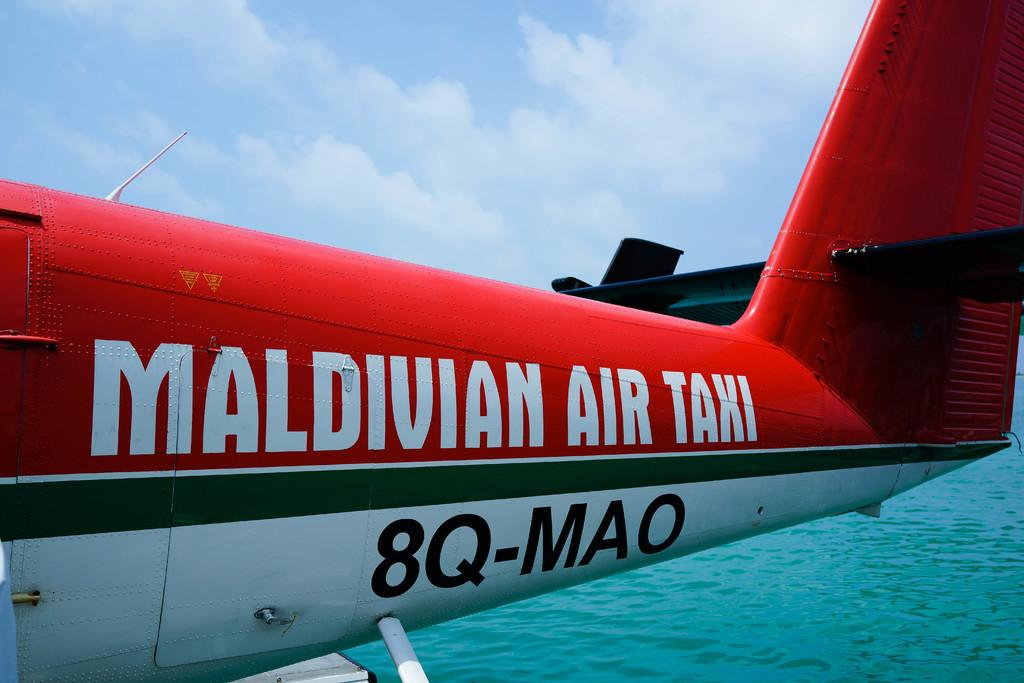What is the main subject of the image? The main subject of the image is the tail of an airplane. What can be seen at the bottom of the image? There is water visible at the bottom of the image. What is visible at the top of the image? The sky is visible at the top of the image. What type of hair can be seen on the dog in the image? There is no dog or hair present in the image; it features the tail of an airplane, water, and the sky. 